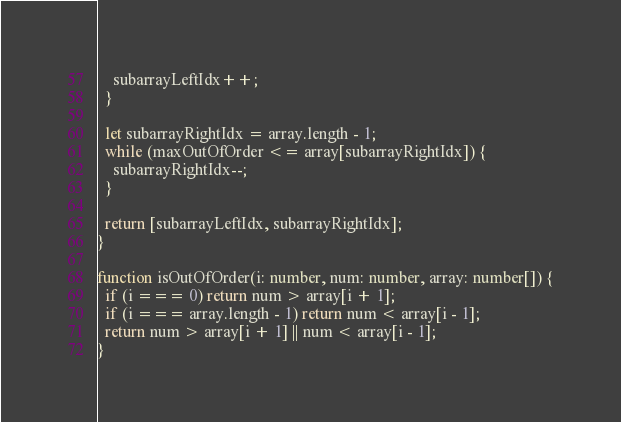Convert code to text. <code><loc_0><loc_0><loc_500><loc_500><_TypeScript_>    subarrayLeftIdx++;
  }

  let subarrayRightIdx = array.length - 1;
  while (maxOutOfOrder <= array[subarrayRightIdx]) {
    subarrayRightIdx--;
  }

  return [subarrayLeftIdx, subarrayRightIdx];
}

function isOutOfOrder(i: number, num: number, array: number[]) {
  if (i === 0) return num > array[i + 1];
  if (i === array.length - 1) return num < array[i - 1];
  return num > array[i + 1] || num < array[i - 1];
}
</code> 